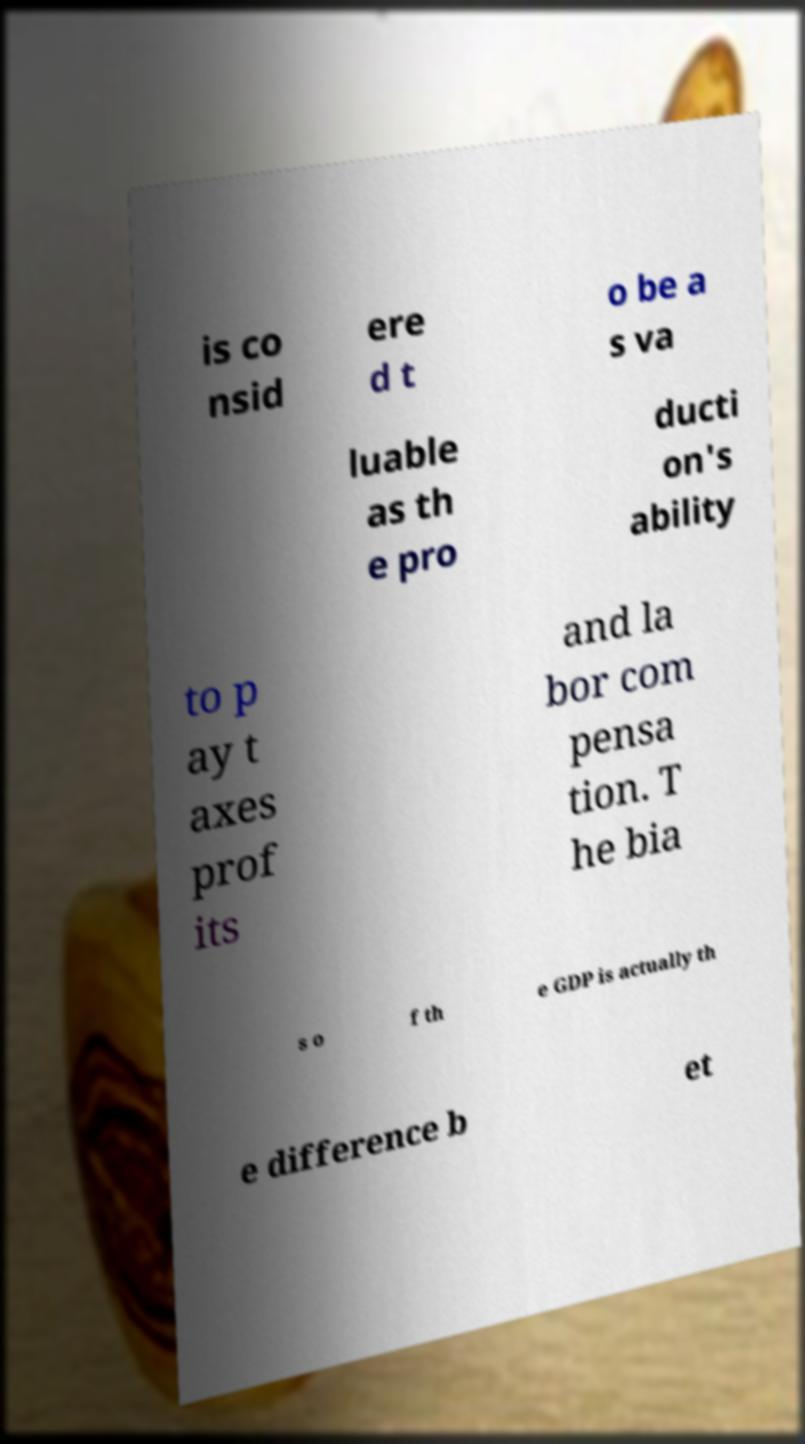Please identify and transcribe the text found in this image. is co nsid ere d t o be a s va luable as th e pro ducti on's ability to p ay t axes prof its and la bor com pensa tion. T he bia s o f th e GDP is actually th e difference b et 